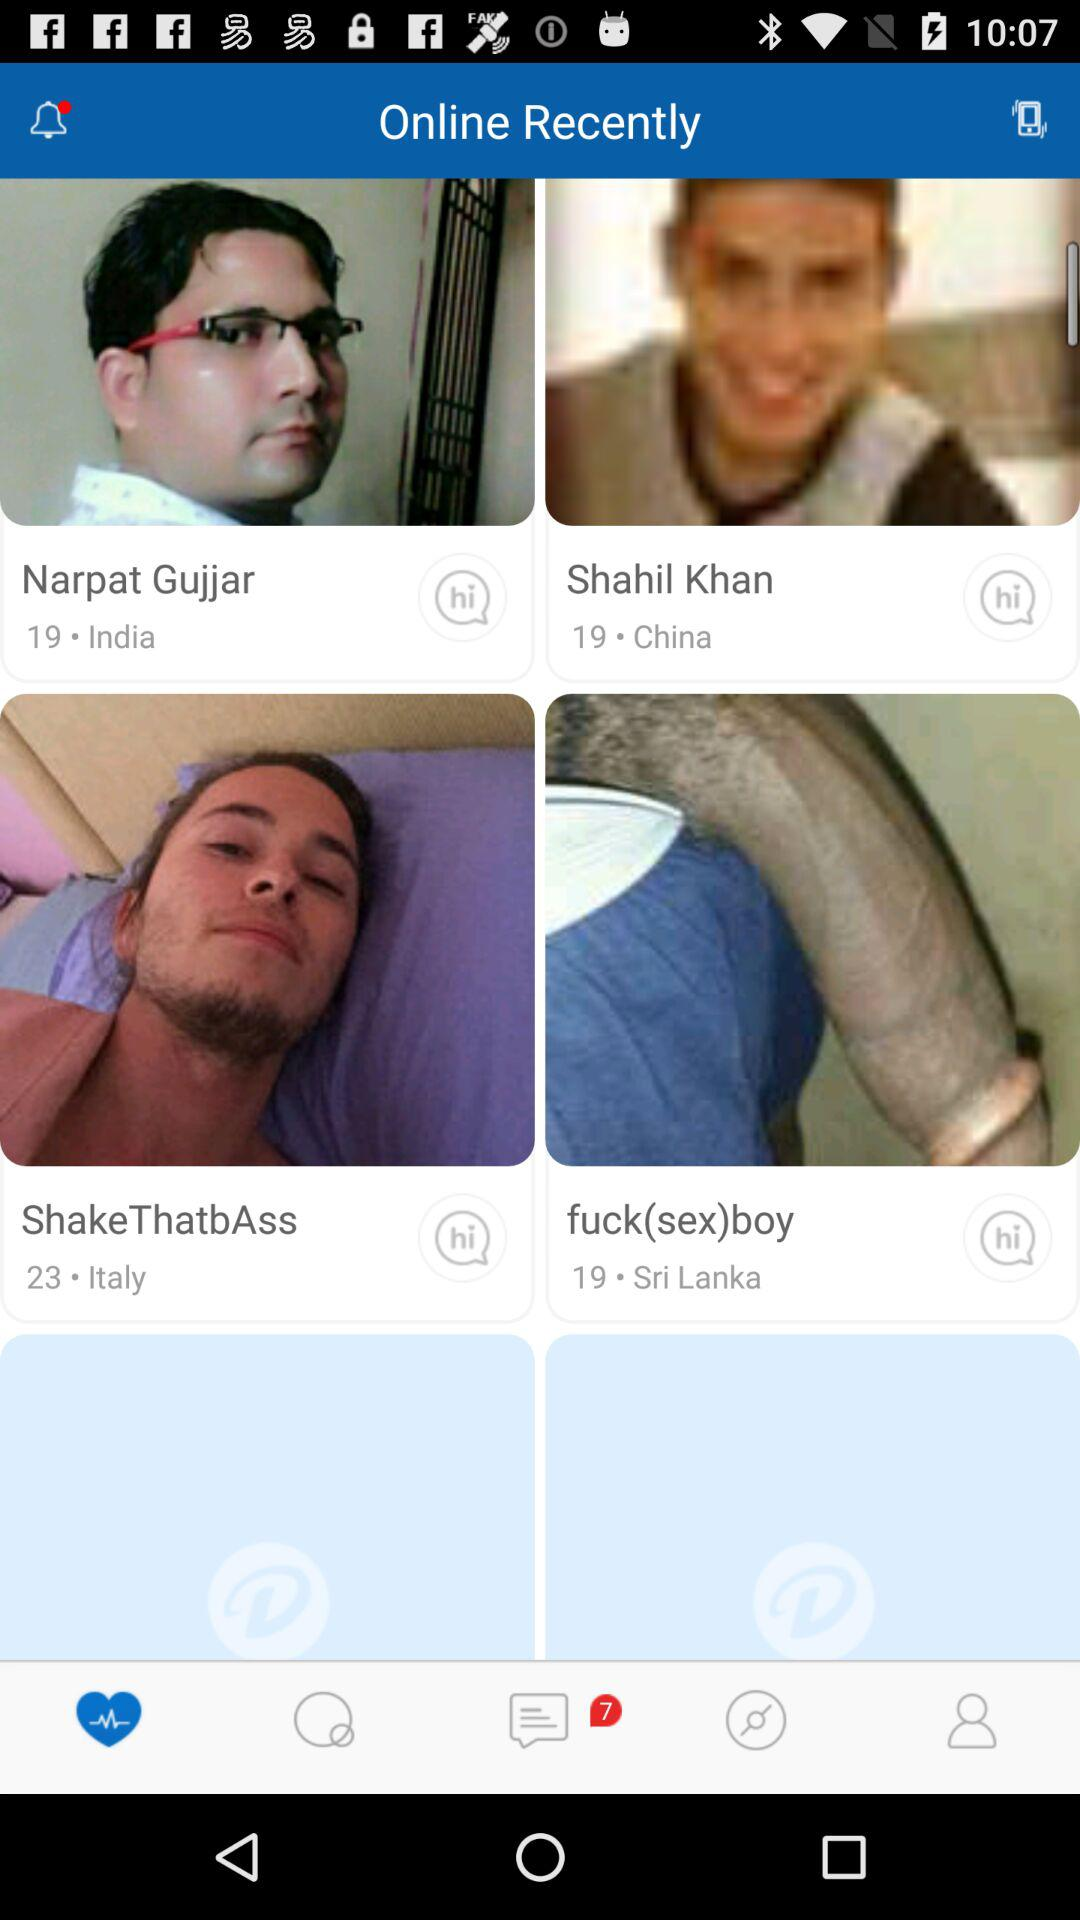What is the user name? The user name is John. 